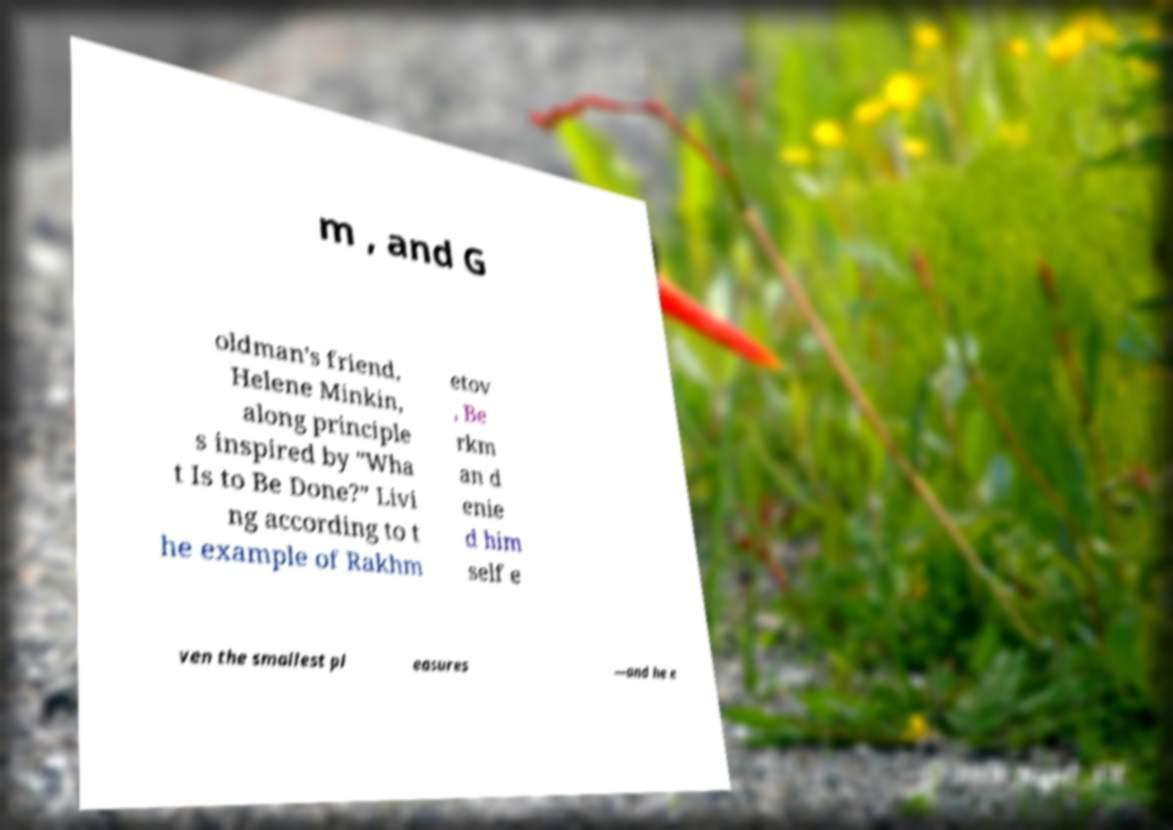Please read and relay the text visible in this image. What does it say? m , and G oldman's friend, Helene Minkin, along principle s inspired by "Wha t Is to Be Done?" Livi ng according to t he example of Rakhm etov , Be rkm an d enie d him self e ven the smallest pl easures —and he e 